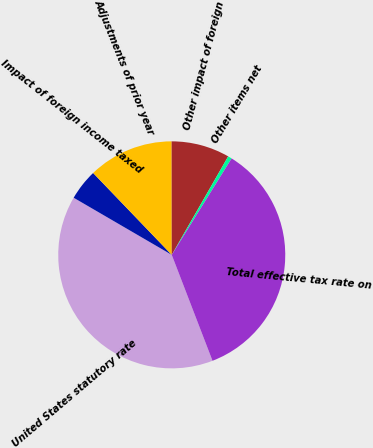<chart> <loc_0><loc_0><loc_500><loc_500><pie_chart><fcel>United States statutory rate<fcel>Impact of foreign income taxed<fcel>Adjustments of prior year<fcel>Other impact of foreign<fcel>Other items net<fcel>Total effective tax rate on<nl><fcel>39.24%<fcel>4.43%<fcel>12.16%<fcel>8.3%<fcel>0.56%<fcel>35.31%<nl></chart> 